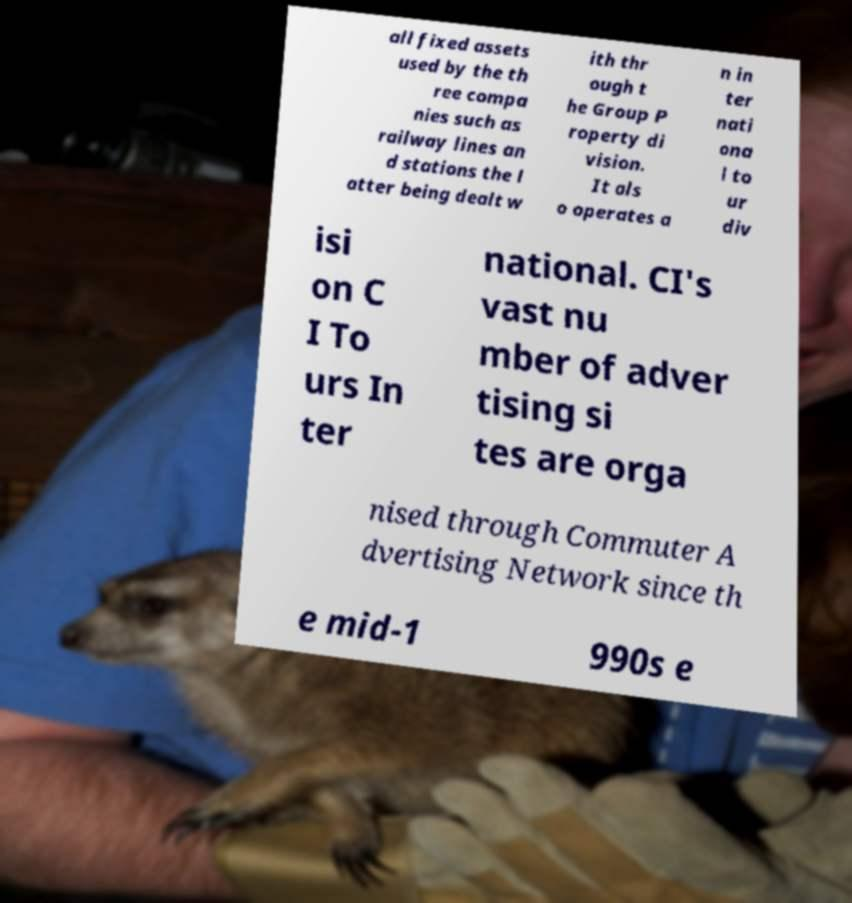Please read and relay the text visible in this image. What does it say? all fixed assets used by the th ree compa nies such as railway lines an d stations the l atter being dealt w ith thr ough t he Group P roperty di vision. It als o operates a n in ter nati ona l to ur div isi on C I To urs In ter national. CI's vast nu mber of adver tising si tes are orga nised through Commuter A dvertising Network since th e mid-1 990s e 